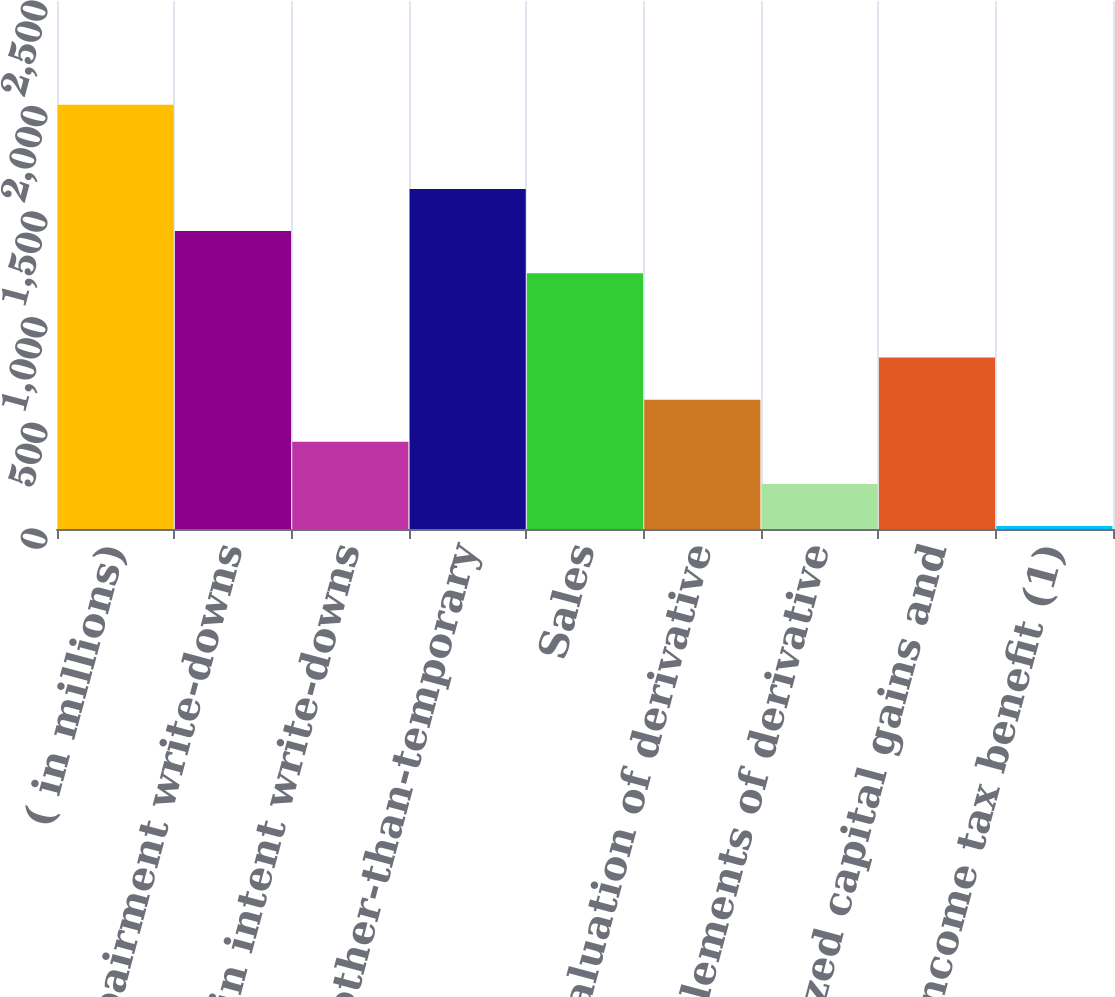<chart> <loc_0><loc_0><loc_500><loc_500><bar_chart><fcel>( in millions)<fcel>Impairment write-downs<fcel>Change in intent write-downs<fcel>Net other-than-temporary<fcel>Sales<fcel>Valuation of derivative<fcel>Settlements of derivative<fcel>Realized capital gains and<fcel>Income tax benefit (1)<nl><fcel>2009<fcel>1410.5<fcel>413<fcel>1610<fcel>1211<fcel>612.5<fcel>213.5<fcel>812<fcel>14<nl></chart> 